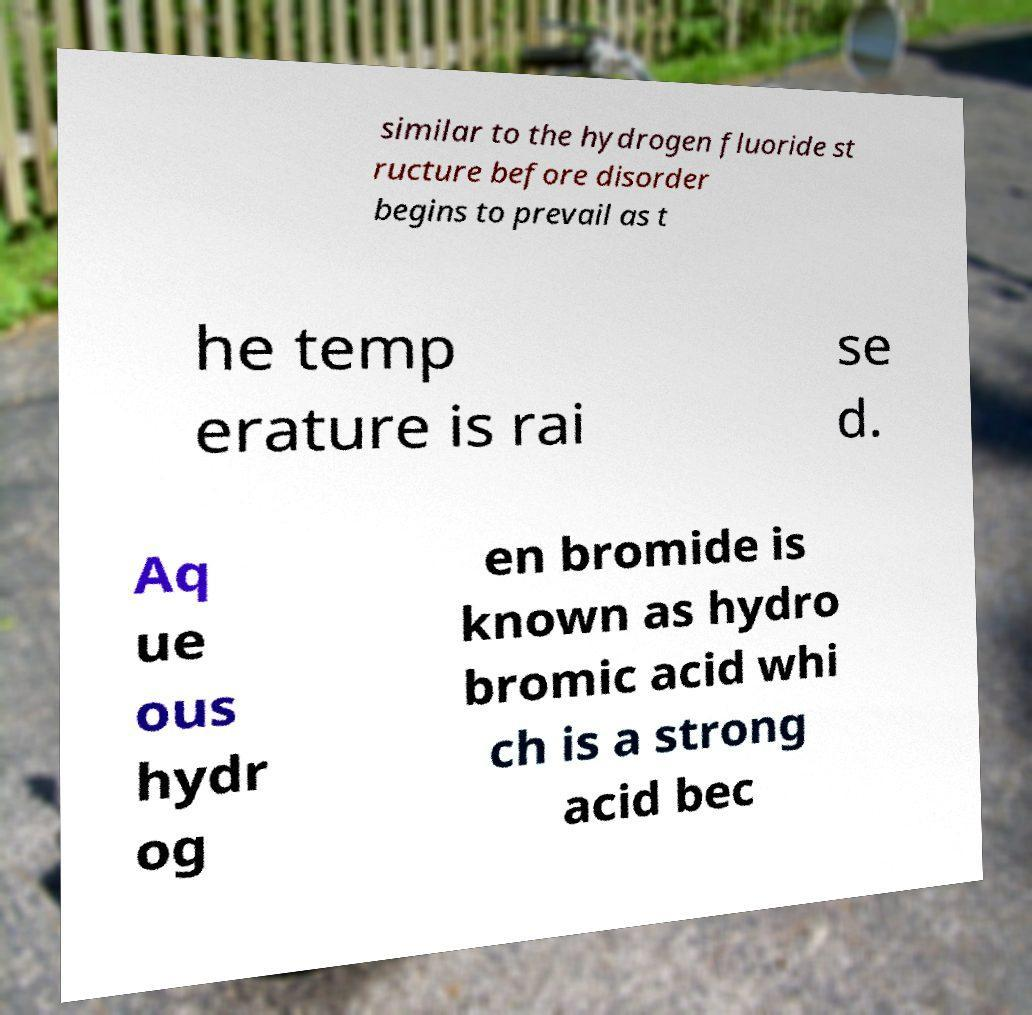What messages or text are displayed in this image? I need them in a readable, typed format. similar to the hydrogen fluoride st ructure before disorder begins to prevail as t he temp erature is rai se d. Aq ue ous hydr og en bromide is known as hydro bromic acid whi ch is a strong acid bec 